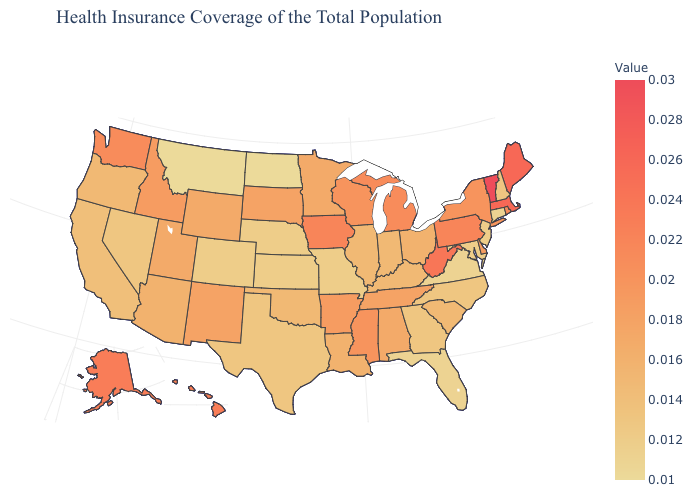Which states have the lowest value in the MidWest?
Be succinct. North Dakota. Does Arizona have a higher value than Rhode Island?
Be succinct. No. Does Massachusetts have the lowest value in the USA?
Concise answer only. No. Does Kansas have the lowest value in the MidWest?
Keep it brief. No. 